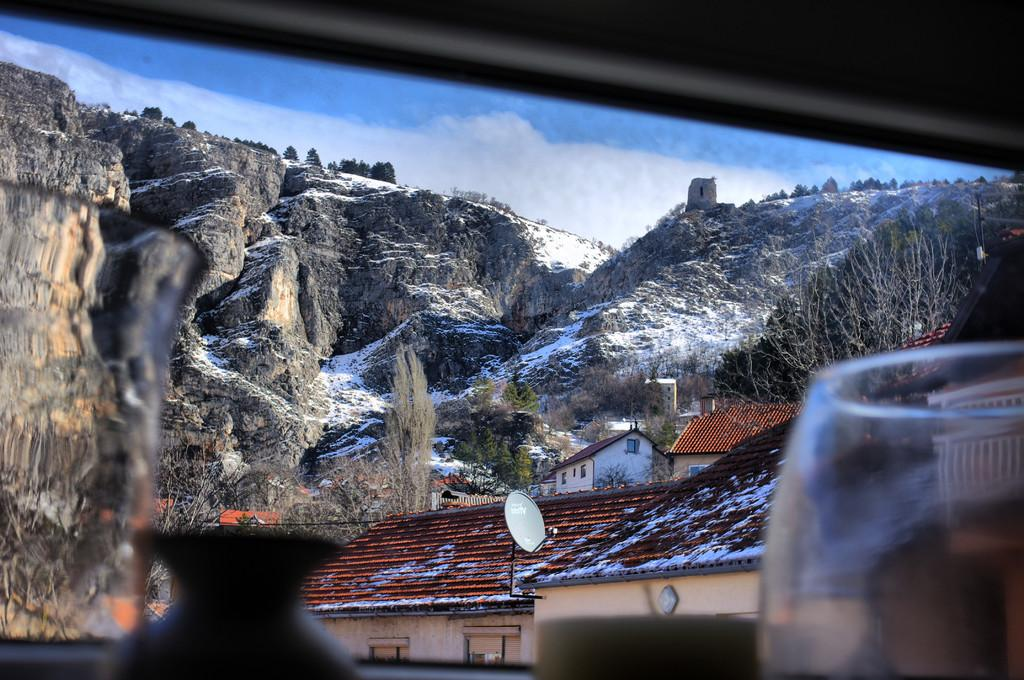What is the perspective of the image? The image is a view from a window. What type of structures can be seen in the image? There are houses in the image. What type of vegetation is present in the image? There are trees in the image. What type of natural landform can be seen in the image? There are mountains in the image. Where are the kittens playing with the poisonous lumber in the image? There are no kittens or lumber present in the image. 